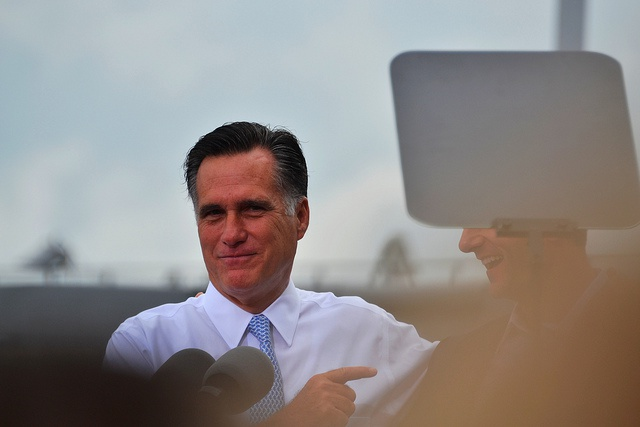Describe the objects in this image and their specific colors. I can see people in darkgray, brown, and maroon tones, people in darkgray, gray, and brown tones, and tie in darkgray and gray tones in this image. 